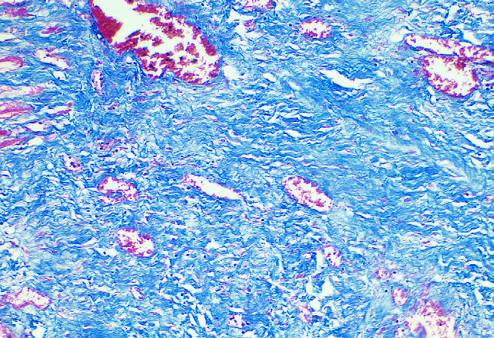s collagen stained blue by the trichrome stain?
Answer the question using a single word or phrase. Yes 